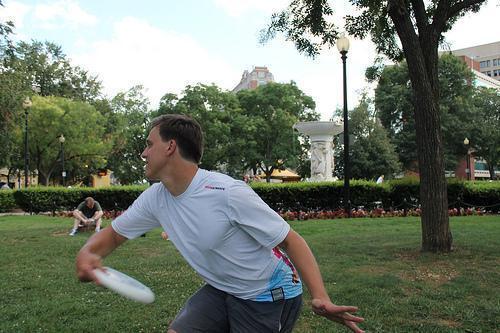How many frisbees are there?
Give a very brief answer. 1. How many people are shown?
Give a very brief answer. 2. 